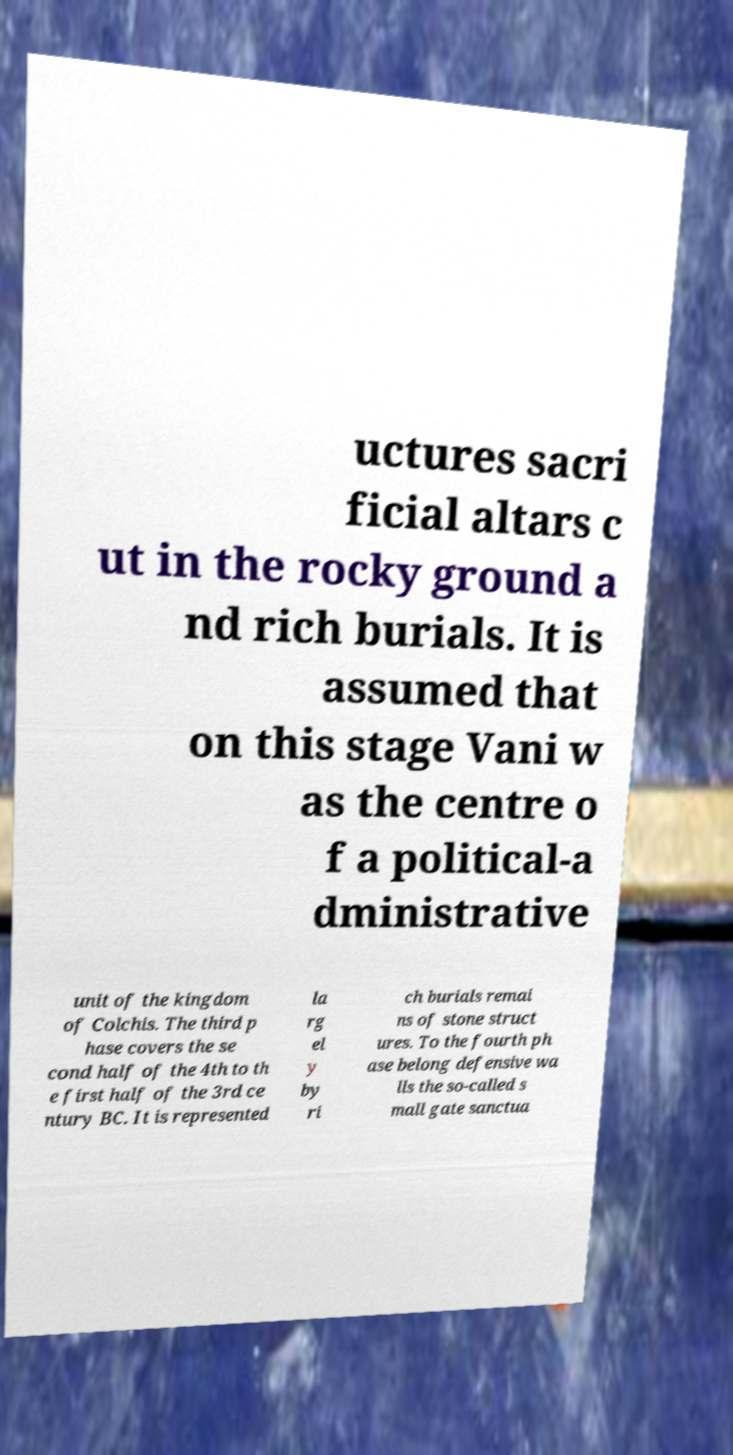What messages or text are displayed in this image? I need them in a readable, typed format. uctures sacri ficial altars c ut in the rocky ground a nd rich burials. It is assumed that on this stage Vani w as the centre o f a political-a dministrative unit of the kingdom of Colchis. The third p hase covers the se cond half of the 4th to th e first half of the 3rd ce ntury BC. It is represented la rg el y by ri ch burials remai ns of stone struct ures. To the fourth ph ase belong defensive wa lls the so-called s mall gate sanctua 